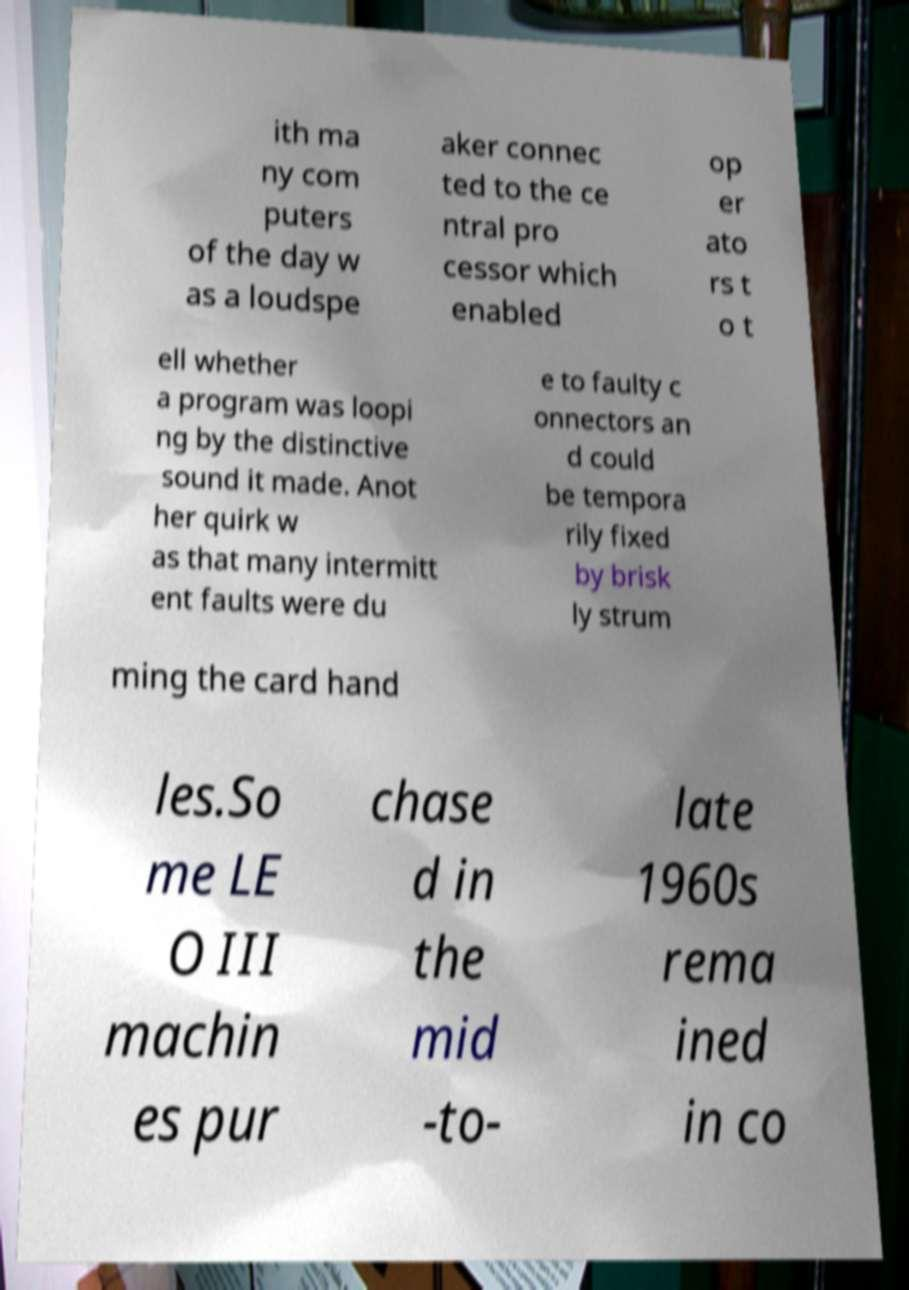What messages or text are displayed in this image? I need them in a readable, typed format. ith ma ny com puters of the day w as a loudspe aker connec ted to the ce ntral pro cessor which enabled op er ato rs t o t ell whether a program was loopi ng by the distinctive sound it made. Anot her quirk w as that many intermitt ent faults were du e to faulty c onnectors an d could be tempora rily fixed by brisk ly strum ming the card hand les.So me LE O III machin es pur chase d in the mid -to- late 1960s rema ined in co 